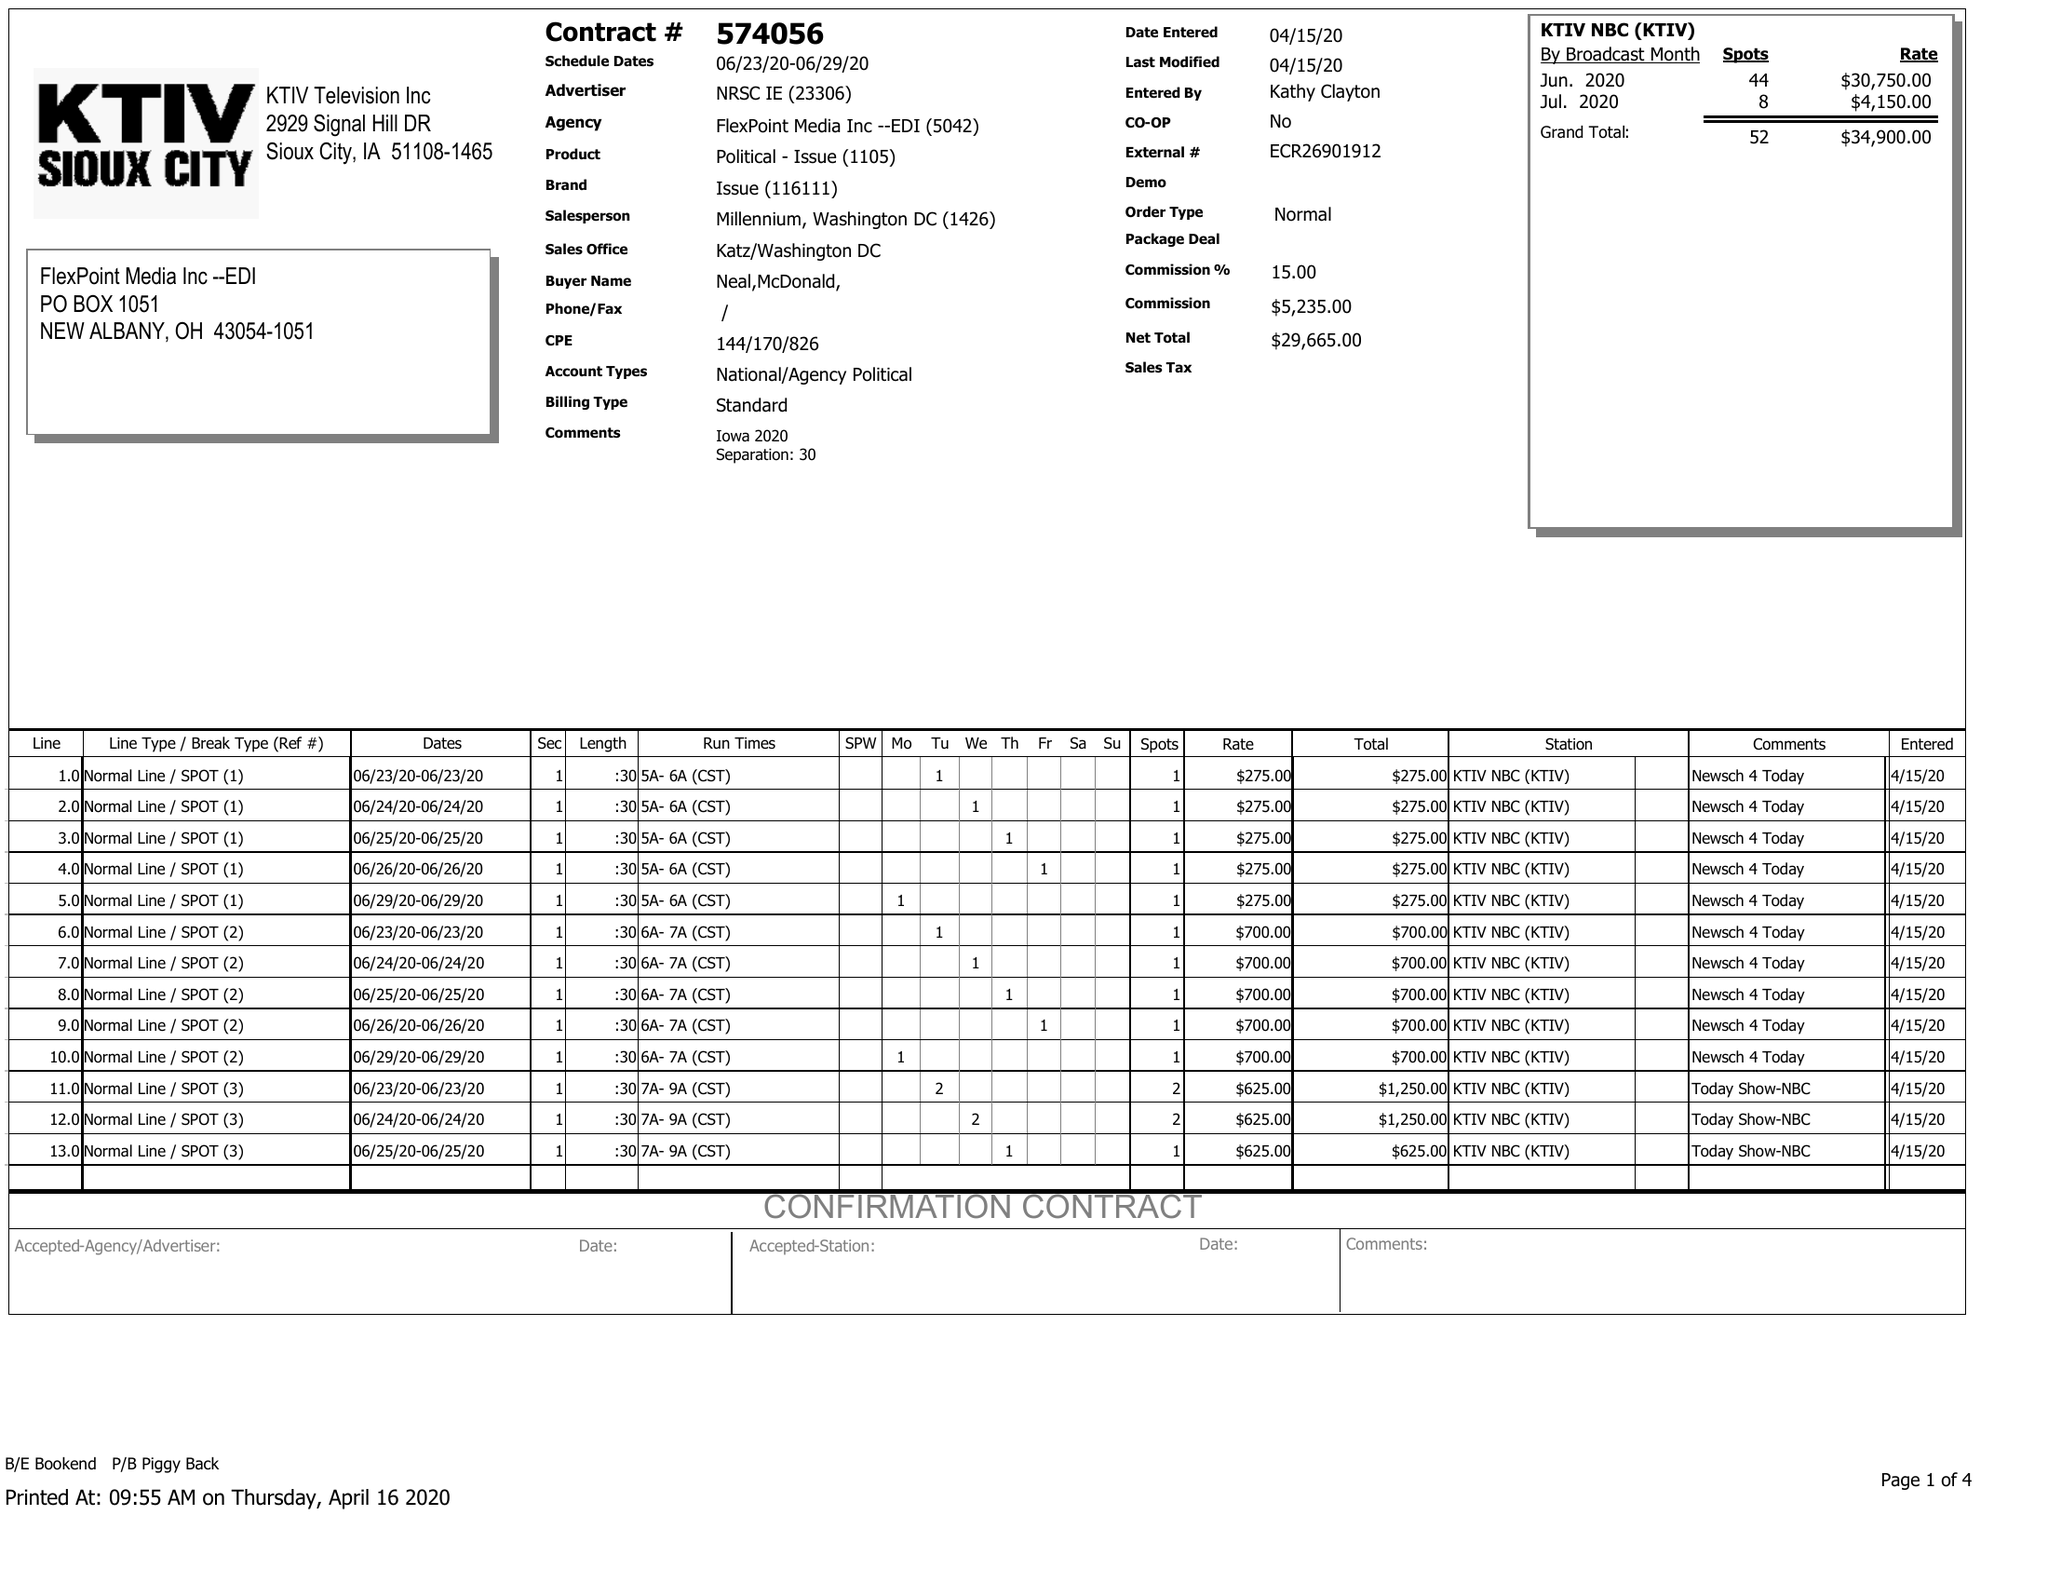What is the value for the advertiser?
Answer the question using a single word or phrase. NRSC IE 